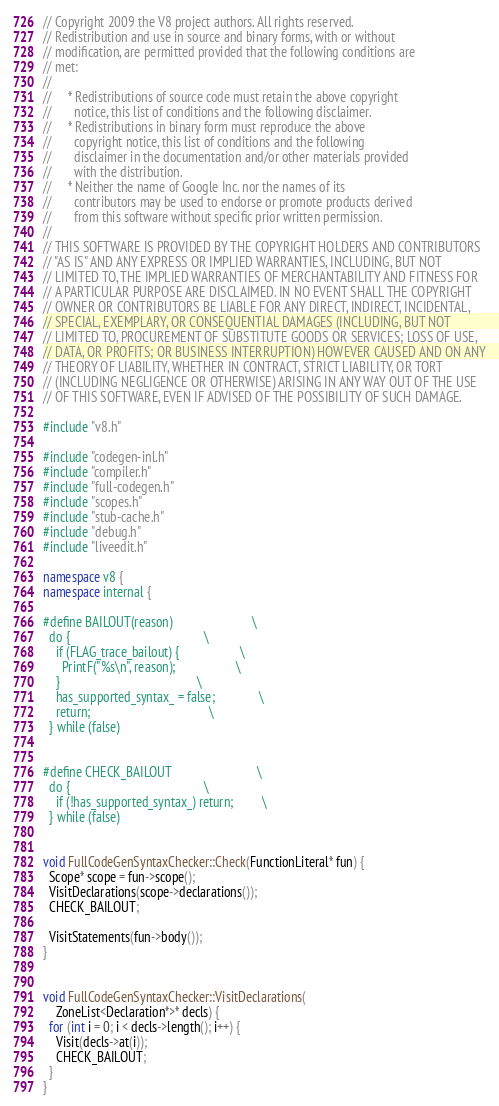<code> <loc_0><loc_0><loc_500><loc_500><_C++_>// Copyright 2009 the V8 project authors. All rights reserved.
// Redistribution and use in source and binary forms, with or without
// modification, are permitted provided that the following conditions are
// met:
//
//     * Redistributions of source code must retain the above copyright
//       notice, this list of conditions and the following disclaimer.
//     * Redistributions in binary form must reproduce the above
//       copyright notice, this list of conditions and the following
//       disclaimer in the documentation and/or other materials provided
//       with the distribution.
//     * Neither the name of Google Inc. nor the names of its
//       contributors may be used to endorse or promote products derived
//       from this software without specific prior written permission.
//
// THIS SOFTWARE IS PROVIDED BY THE COPYRIGHT HOLDERS AND CONTRIBUTORS
// "AS IS" AND ANY EXPRESS OR IMPLIED WARRANTIES, INCLUDING, BUT NOT
// LIMITED TO, THE IMPLIED WARRANTIES OF MERCHANTABILITY AND FITNESS FOR
// A PARTICULAR PURPOSE ARE DISCLAIMED. IN NO EVENT SHALL THE COPYRIGHT
// OWNER OR CONTRIBUTORS BE LIABLE FOR ANY DIRECT, INDIRECT, INCIDENTAL,
// SPECIAL, EXEMPLARY, OR CONSEQUENTIAL DAMAGES (INCLUDING, BUT NOT
// LIMITED TO, PROCUREMENT OF SUBSTITUTE GOODS OR SERVICES; LOSS OF USE,
// DATA, OR PROFITS; OR BUSINESS INTERRUPTION) HOWEVER CAUSED AND ON ANY
// THEORY OF LIABILITY, WHETHER IN CONTRACT, STRICT LIABILITY, OR TORT
// (INCLUDING NEGLIGENCE OR OTHERWISE) ARISING IN ANY WAY OUT OF THE USE
// OF THIS SOFTWARE, EVEN IF ADVISED OF THE POSSIBILITY OF SUCH DAMAGE.

#include "v8.h"

#include "codegen-inl.h"
#include "compiler.h"
#include "full-codegen.h"
#include "scopes.h"
#include "stub-cache.h"
#include "debug.h"
#include "liveedit.h"

namespace v8 {
namespace internal {

#define BAILOUT(reason)                         \
  do {                                          \
    if (FLAG_trace_bailout) {                   \
      PrintF("%s\n", reason);                   \
    }                                           \
    has_supported_syntax_ = false;              \
    return;                                     \
  } while (false)


#define CHECK_BAILOUT                           \
  do {                                          \
    if (!has_supported_syntax_) return;         \
  } while (false)


void FullCodeGenSyntaxChecker::Check(FunctionLiteral* fun) {
  Scope* scope = fun->scope();
  VisitDeclarations(scope->declarations());
  CHECK_BAILOUT;

  VisitStatements(fun->body());
}


void FullCodeGenSyntaxChecker::VisitDeclarations(
    ZoneList<Declaration*>* decls) {
  for (int i = 0; i < decls->length(); i++) {
    Visit(decls->at(i));
    CHECK_BAILOUT;
  }
}

</code> 